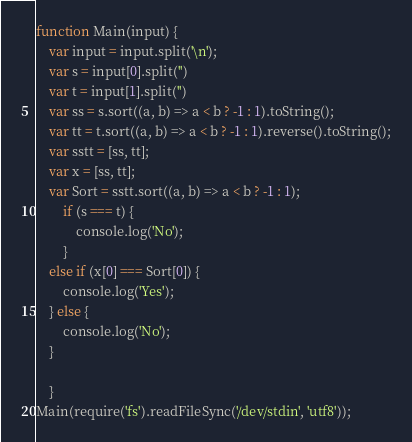Convert code to text. <code><loc_0><loc_0><loc_500><loc_500><_JavaScript_>function Main(input) {
    var input = input.split('\n');
    var s = input[0].split('')
    var t = input[1].split('')
    var ss = s.sort((a, b) => a < b ? -1 : 1).toString();
    var tt = t.sort((a, b) => a < b ? -1 : 1).reverse().toString();
    var sstt = [ss, tt];
    var x = [ss, tt];
    var Sort = sstt.sort((a, b) => a < b ? -1 : 1);
        if (s === t) {
            console.log('No');
        }
    else if (x[0] === Sort[0]) {
        console.log('Yes');
    } else {
        console.log('No');
    }

    }
Main(require('fs').readFileSync('/dev/stdin', 'utf8'));</code> 